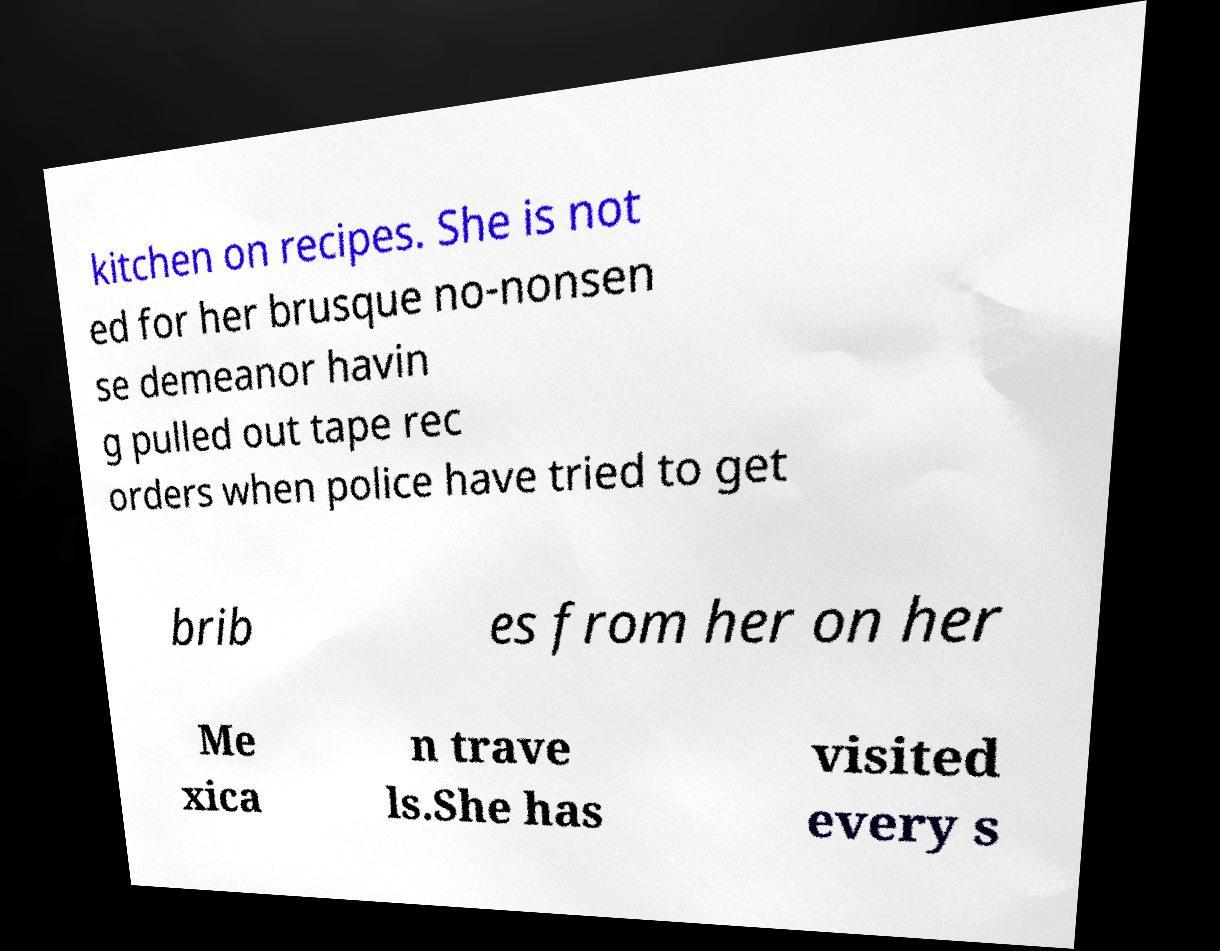Can you accurately transcribe the text from the provided image for me? kitchen on recipes. She is not ed for her brusque no-nonsen se demeanor havin g pulled out tape rec orders when police have tried to get brib es from her on her Me xica n trave ls.She has visited every s 